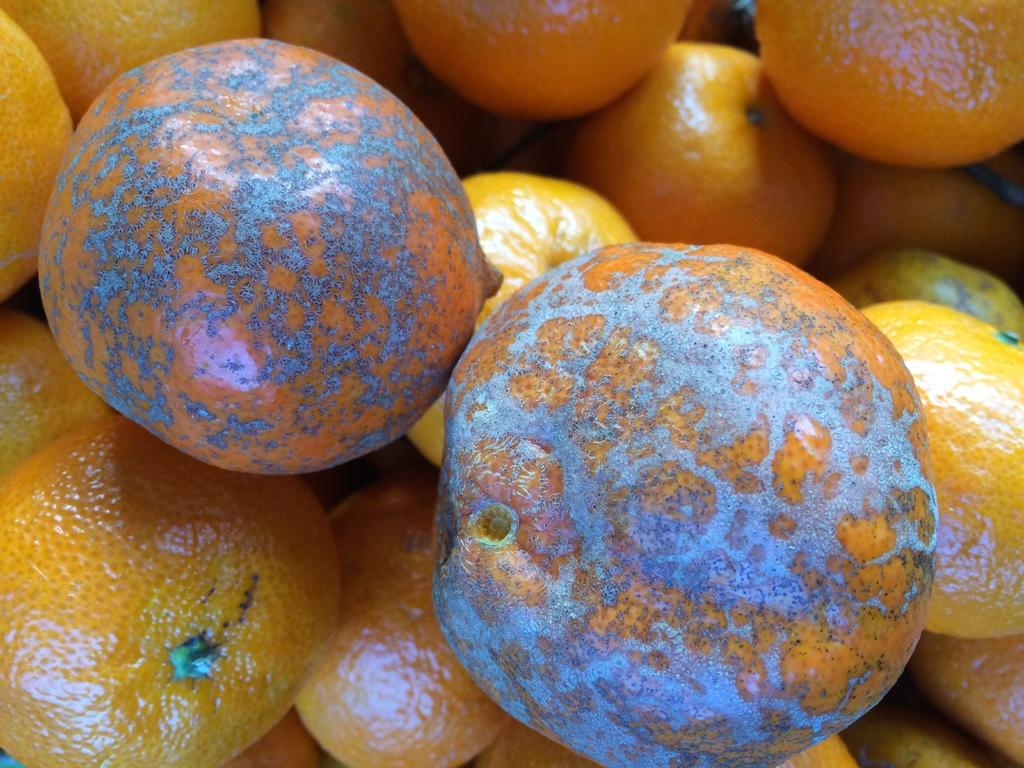What type of fruits are present in the image? There are orange fruits in the image. Can you describe any unique features of these fruits? Yes, there are blue color spots on the orange fruits. How does the fruit increase in size in the image? The fruit does not increase in size in the image; it is already fully grown with blue color spots. 